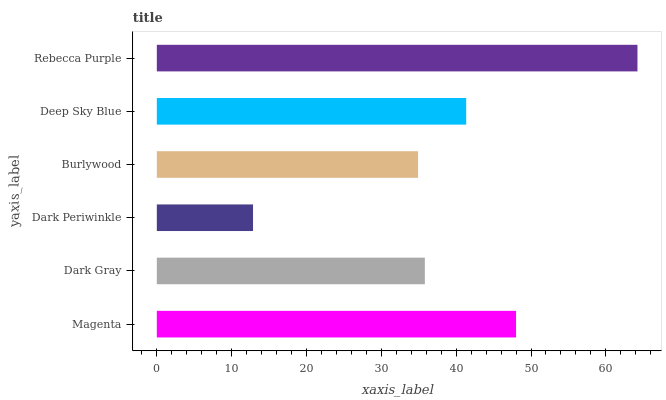Is Dark Periwinkle the minimum?
Answer yes or no. Yes. Is Rebecca Purple the maximum?
Answer yes or no. Yes. Is Dark Gray the minimum?
Answer yes or no. No. Is Dark Gray the maximum?
Answer yes or no. No. Is Magenta greater than Dark Gray?
Answer yes or no. Yes. Is Dark Gray less than Magenta?
Answer yes or no. Yes. Is Dark Gray greater than Magenta?
Answer yes or no. No. Is Magenta less than Dark Gray?
Answer yes or no. No. Is Deep Sky Blue the high median?
Answer yes or no. Yes. Is Dark Gray the low median?
Answer yes or no. Yes. Is Dark Gray the high median?
Answer yes or no. No. Is Rebecca Purple the low median?
Answer yes or no. No. 